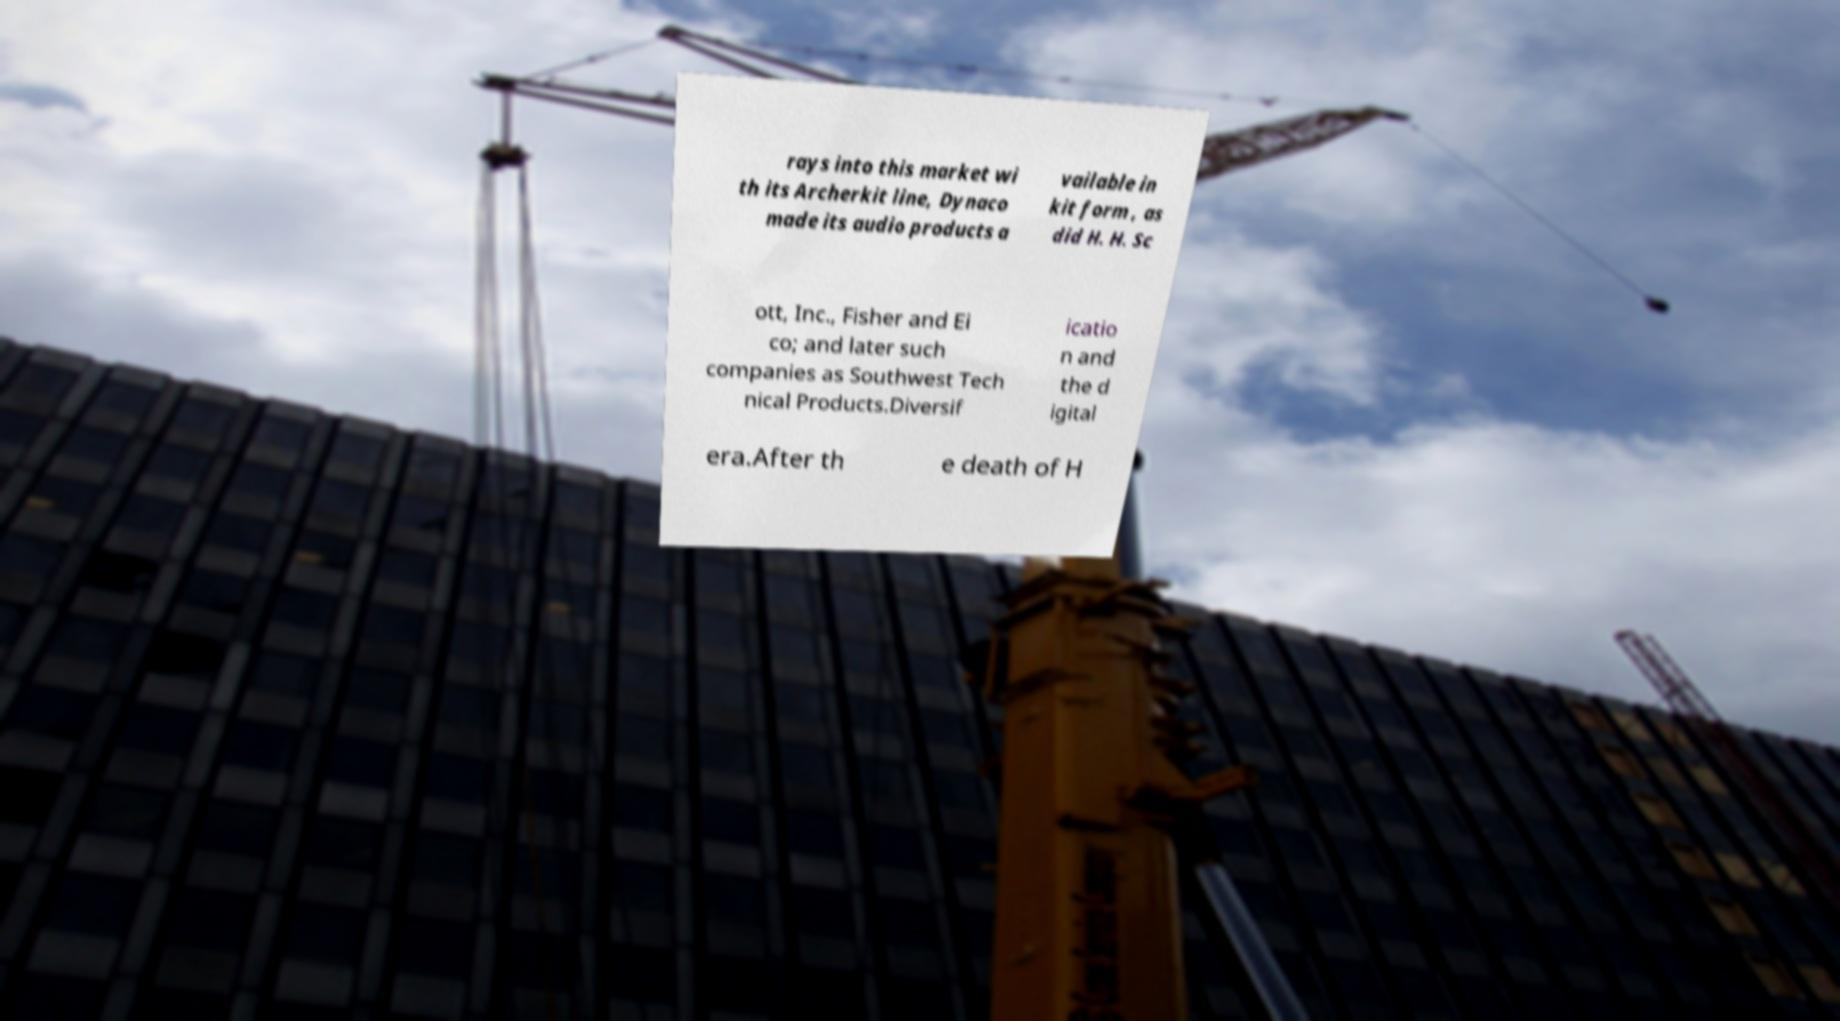For documentation purposes, I need the text within this image transcribed. Could you provide that? rays into this market wi th its Archerkit line, Dynaco made its audio products a vailable in kit form , as did H. H. Sc ott, Inc., Fisher and Ei co; and later such companies as Southwest Tech nical Products.Diversif icatio n and the d igital era.After th e death of H 